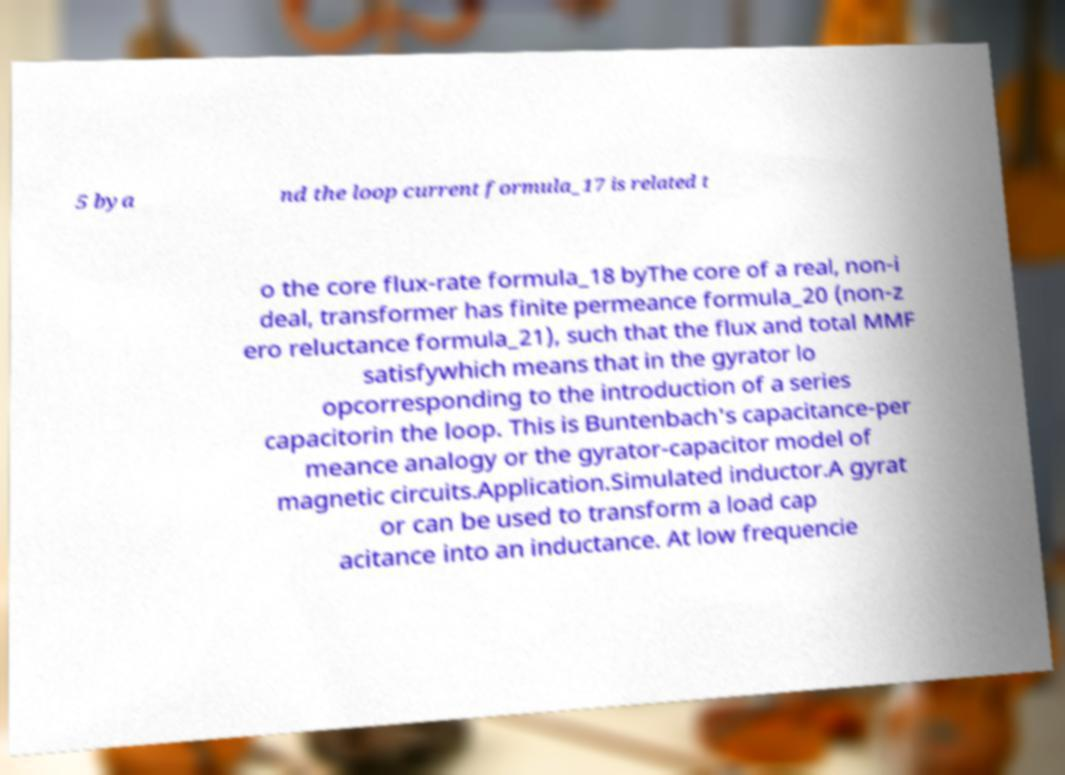What messages or text are displayed in this image? I need them in a readable, typed format. 5 bya nd the loop current formula_17 is related t o the core flux-rate formula_18 byThe core of a real, non-i deal, transformer has finite permeance formula_20 (non-z ero reluctance formula_21), such that the flux and total MMF satisfywhich means that in the gyrator lo opcorresponding to the introduction of a series capacitorin the loop. This is Buntenbach's capacitance-per meance analogy or the gyrator-capacitor model of magnetic circuits.Application.Simulated inductor.A gyrat or can be used to transform a load cap acitance into an inductance. At low frequencie 